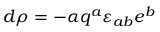Convert formula to latex. <formula><loc_0><loc_0><loc_500><loc_500>d \rho = - { \alpha } q ^ { a } \varepsilon _ { a b } e ^ { b }</formula> 